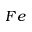Convert formula to latex. <formula><loc_0><loc_0><loc_500><loc_500>F e</formula> 